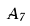<formula> <loc_0><loc_0><loc_500><loc_500>\tilde { A } _ { 7 }</formula> 